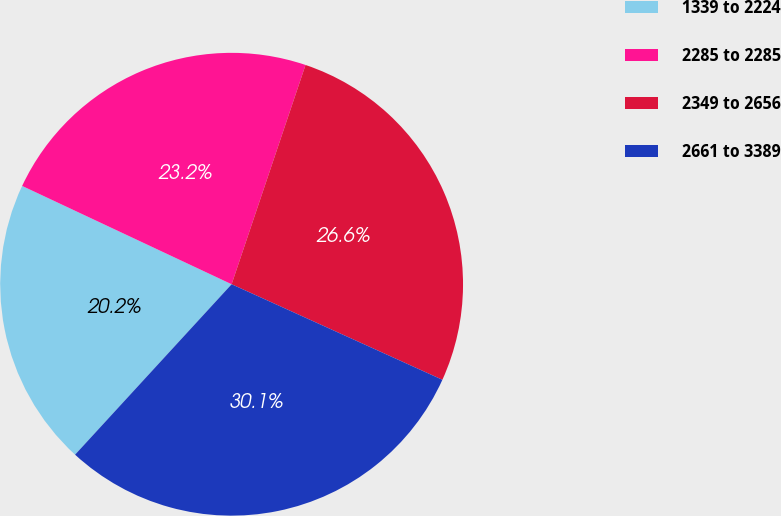Convert chart to OTSL. <chart><loc_0><loc_0><loc_500><loc_500><pie_chart><fcel>1339 to 2224<fcel>2285 to 2285<fcel>2349 to 2656<fcel>2661 to 3389<nl><fcel>20.16%<fcel>23.19%<fcel>26.6%<fcel>30.05%<nl></chart> 